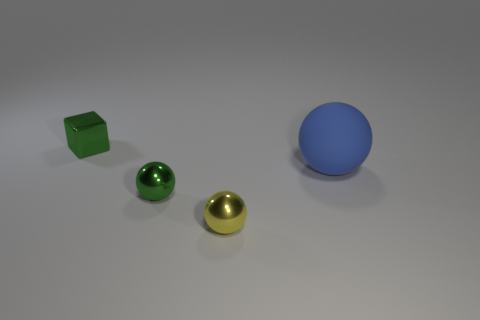Subtract all rubber spheres. How many spheres are left? 2 Add 1 metal things. How many objects exist? 5 Subtract all purple balls. Subtract all purple cylinders. How many balls are left? 3 Subtract all large cylinders. Subtract all small yellow objects. How many objects are left? 3 Add 3 small cubes. How many small cubes are left? 4 Add 4 small green cubes. How many small green cubes exist? 5 Subtract 0 cyan cylinders. How many objects are left? 4 Subtract all balls. How many objects are left? 1 